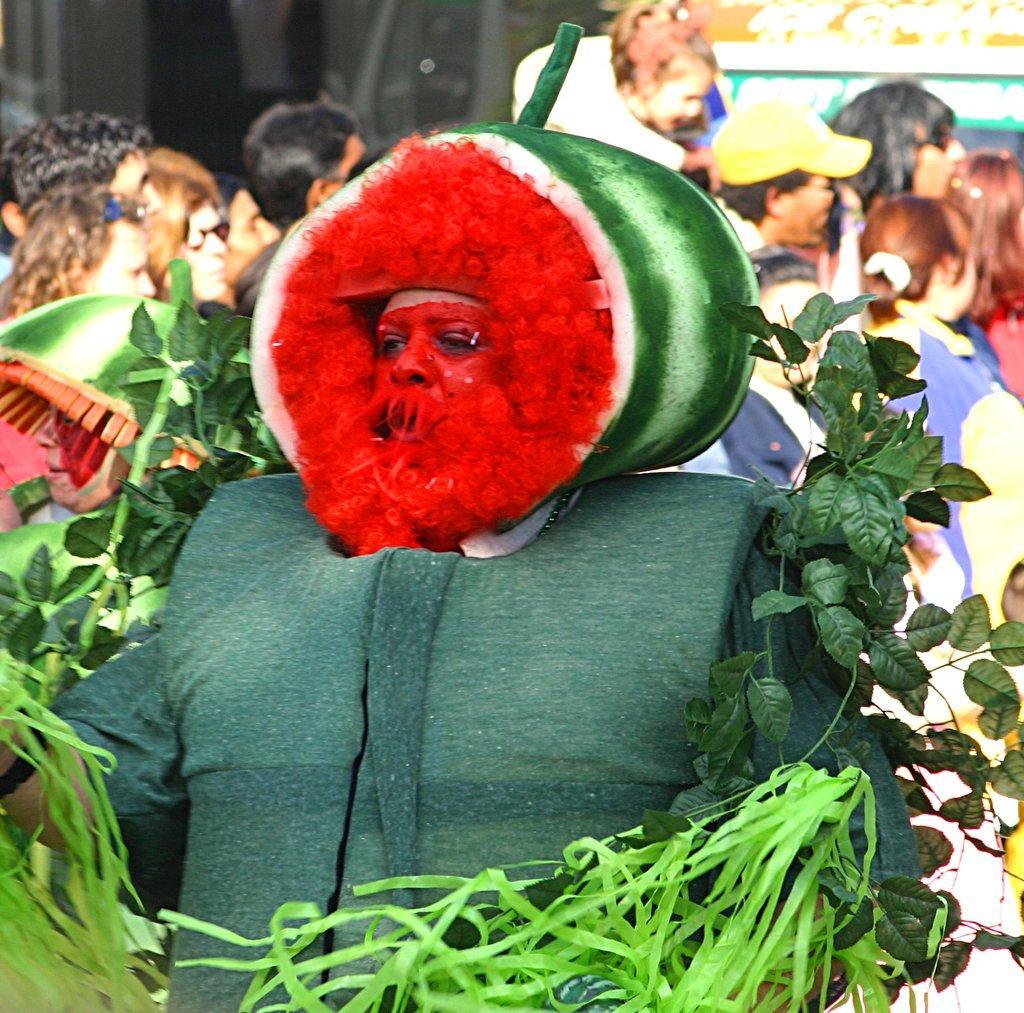Can you describe this image briefly? In the image there is a person with costumes and leaves around him. Behind the person there are many people standing and also there is a blur background. 